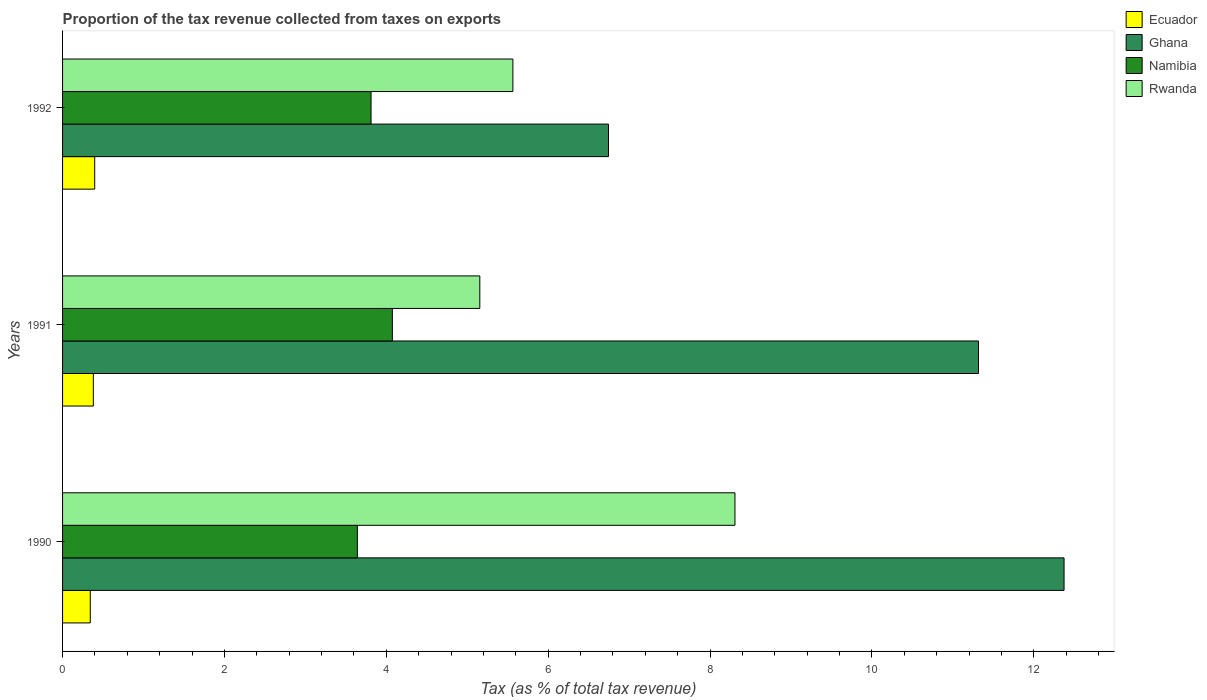Are the number of bars on each tick of the Y-axis equal?
Your response must be concise. Yes. What is the label of the 3rd group of bars from the top?
Offer a terse response. 1990. In how many cases, is the number of bars for a given year not equal to the number of legend labels?
Provide a succinct answer. 0. What is the proportion of the tax revenue collected in Namibia in 1991?
Your answer should be compact. 4.07. Across all years, what is the maximum proportion of the tax revenue collected in Rwanda?
Keep it short and to the point. 8.31. Across all years, what is the minimum proportion of the tax revenue collected in Rwanda?
Ensure brevity in your answer.  5.16. In which year was the proportion of the tax revenue collected in Rwanda maximum?
Your answer should be very brief. 1990. What is the total proportion of the tax revenue collected in Ghana in the graph?
Your answer should be compact. 30.44. What is the difference between the proportion of the tax revenue collected in Ecuador in 1990 and that in 1991?
Your answer should be very brief. -0.04. What is the difference between the proportion of the tax revenue collected in Rwanda in 1992 and the proportion of the tax revenue collected in Ghana in 1991?
Offer a terse response. -5.75. What is the average proportion of the tax revenue collected in Ecuador per year?
Make the answer very short. 0.37. In the year 1990, what is the difference between the proportion of the tax revenue collected in Namibia and proportion of the tax revenue collected in Rwanda?
Provide a succinct answer. -4.67. In how many years, is the proportion of the tax revenue collected in Namibia greater than 2.8 %?
Your answer should be compact. 3. What is the ratio of the proportion of the tax revenue collected in Namibia in 1990 to that in 1992?
Keep it short and to the point. 0.96. What is the difference between the highest and the second highest proportion of the tax revenue collected in Ghana?
Provide a short and direct response. 1.06. What is the difference between the highest and the lowest proportion of the tax revenue collected in Namibia?
Keep it short and to the point. 0.43. Is it the case that in every year, the sum of the proportion of the tax revenue collected in Ghana and proportion of the tax revenue collected in Rwanda is greater than the sum of proportion of the tax revenue collected in Ecuador and proportion of the tax revenue collected in Namibia?
Provide a short and direct response. No. What does the 1st bar from the top in 1990 represents?
Keep it short and to the point. Rwanda. What does the 4th bar from the bottom in 1991 represents?
Offer a terse response. Rwanda. How many bars are there?
Your answer should be compact. 12. What is the difference between two consecutive major ticks on the X-axis?
Offer a very short reply. 2. Are the values on the major ticks of X-axis written in scientific E-notation?
Make the answer very short. No. Does the graph contain any zero values?
Provide a short and direct response. No. What is the title of the graph?
Your response must be concise. Proportion of the tax revenue collected from taxes on exports. Does "Guyana" appear as one of the legend labels in the graph?
Keep it short and to the point. No. What is the label or title of the X-axis?
Keep it short and to the point. Tax (as % of total tax revenue). What is the Tax (as % of total tax revenue) in Ecuador in 1990?
Provide a short and direct response. 0.34. What is the Tax (as % of total tax revenue) in Ghana in 1990?
Make the answer very short. 12.37. What is the Tax (as % of total tax revenue) of Namibia in 1990?
Offer a terse response. 3.64. What is the Tax (as % of total tax revenue) in Rwanda in 1990?
Give a very brief answer. 8.31. What is the Tax (as % of total tax revenue) of Ecuador in 1991?
Offer a terse response. 0.38. What is the Tax (as % of total tax revenue) of Ghana in 1991?
Provide a succinct answer. 11.32. What is the Tax (as % of total tax revenue) in Namibia in 1991?
Offer a very short reply. 4.07. What is the Tax (as % of total tax revenue) in Rwanda in 1991?
Make the answer very short. 5.16. What is the Tax (as % of total tax revenue) in Ecuador in 1992?
Make the answer very short. 0.4. What is the Tax (as % of total tax revenue) of Ghana in 1992?
Your response must be concise. 6.75. What is the Tax (as % of total tax revenue) of Namibia in 1992?
Ensure brevity in your answer.  3.81. What is the Tax (as % of total tax revenue) in Rwanda in 1992?
Offer a terse response. 5.56. Across all years, what is the maximum Tax (as % of total tax revenue) of Ecuador?
Provide a short and direct response. 0.4. Across all years, what is the maximum Tax (as % of total tax revenue) in Ghana?
Offer a terse response. 12.37. Across all years, what is the maximum Tax (as % of total tax revenue) of Namibia?
Make the answer very short. 4.07. Across all years, what is the maximum Tax (as % of total tax revenue) in Rwanda?
Your answer should be very brief. 8.31. Across all years, what is the minimum Tax (as % of total tax revenue) of Ecuador?
Your response must be concise. 0.34. Across all years, what is the minimum Tax (as % of total tax revenue) of Ghana?
Your answer should be very brief. 6.75. Across all years, what is the minimum Tax (as % of total tax revenue) in Namibia?
Offer a very short reply. 3.64. Across all years, what is the minimum Tax (as % of total tax revenue) of Rwanda?
Ensure brevity in your answer.  5.16. What is the total Tax (as % of total tax revenue) in Ecuador in the graph?
Provide a short and direct response. 1.12. What is the total Tax (as % of total tax revenue) in Ghana in the graph?
Your answer should be compact. 30.44. What is the total Tax (as % of total tax revenue) of Namibia in the graph?
Make the answer very short. 11.53. What is the total Tax (as % of total tax revenue) in Rwanda in the graph?
Provide a succinct answer. 19.03. What is the difference between the Tax (as % of total tax revenue) in Ecuador in 1990 and that in 1991?
Offer a terse response. -0.04. What is the difference between the Tax (as % of total tax revenue) in Ghana in 1990 and that in 1991?
Offer a terse response. 1.06. What is the difference between the Tax (as % of total tax revenue) of Namibia in 1990 and that in 1991?
Offer a terse response. -0.43. What is the difference between the Tax (as % of total tax revenue) of Rwanda in 1990 and that in 1991?
Keep it short and to the point. 3.15. What is the difference between the Tax (as % of total tax revenue) in Ecuador in 1990 and that in 1992?
Offer a terse response. -0.05. What is the difference between the Tax (as % of total tax revenue) of Ghana in 1990 and that in 1992?
Give a very brief answer. 5.63. What is the difference between the Tax (as % of total tax revenue) of Namibia in 1990 and that in 1992?
Provide a short and direct response. -0.17. What is the difference between the Tax (as % of total tax revenue) in Rwanda in 1990 and that in 1992?
Ensure brevity in your answer.  2.74. What is the difference between the Tax (as % of total tax revenue) of Ecuador in 1991 and that in 1992?
Offer a very short reply. -0.02. What is the difference between the Tax (as % of total tax revenue) of Ghana in 1991 and that in 1992?
Provide a succinct answer. 4.57. What is the difference between the Tax (as % of total tax revenue) of Namibia in 1991 and that in 1992?
Your answer should be compact. 0.26. What is the difference between the Tax (as % of total tax revenue) of Rwanda in 1991 and that in 1992?
Ensure brevity in your answer.  -0.41. What is the difference between the Tax (as % of total tax revenue) of Ecuador in 1990 and the Tax (as % of total tax revenue) of Ghana in 1991?
Your answer should be very brief. -10.97. What is the difference between the Tax (as % of total tax revenue) in Ecuador in 1990 and the Tax (as % of total tax revenue) in Namibia in 1991?
Make the answer very short. -3.73. What is the difference between the Tax (as % of total tax revenue) of Ecuador in 1990 and the Tax (as % of total tax revenue) of Rwanda in 1991?
Your answer should be very brief. -4.81. What is the difference between the Tax (as % of total tax revenue) in Ghana in 1990 and the Tax (as % of total tax revenue) in Namibia in 1991?
Your answer should be very brief. 8.3. What is the difference between the Tax (as % of total tax revenue) of Ghana in 1990 and the Tax (as % of total tax revenue) of Rwanda in 1991?
Your response must be concise. 7.22. What is the difference between the Tax (as % of total tax revenue) in Namibia in 1990 and the Tax (as % of total tax revenue) in Rwanda in 1991?
Your answer should be very brief. -1.51. What is the difference between the Tax (as % of total tax revenue) in Ecuador in 1990 and the Tax (as % of total tax revenue) in Ghana in 1992?
Your answer should be very brief. -6.4. What is the difference between the Tax (as % of total tax revenue) in Ecuador in 1990 and the Tax (as % of total tax revenue) in Namibia in 1992?
Your response must be concise. -3.47. What is the difference between the Tax (as % of total tax revenue) in Ecuador in 1990 and the Tax (as % of total tax revenue) in Rwanda in 1992?
Your answer should be compact. -5.22. What is the difference between the Tax (as % of total tax revenue) in Ghana in 1990 and the Tax (as % of total tax revenue) in Namibia in 1992?
Provide a short and direct response. 8.56. What is the difference between the Tax (as % of total tax revenue) in Ghana in 1990 and the Tax (as % of total tax revenue) in Rwanda in 1992?
Make the answer very short. 6.81. What is the difference between the Tax (as % of total tax revenue) of Namibia in 1990 and the Tax (as % of total tax revenue) of Rwanda in 1992?
Your response must be concise. -1.92. What is the difference between the Tax (as % of total tax revenue) in Ecuador in 1991 and the Tax (as % of total tax revenue) in Ghana in 1992?
Provide a succinct answer. -6.37. What is the difference between the Tax (as % of total tax revenue) of Ecuador in 1991 and the Tax (as % of total tax revenue) of Namibia in 1992?
Make the answer very short. -3.43. What is the difference between the Tax (as % of total tax revenue) in Ecuador in 1991 and the Tax (as % of total tax revenue) in Rwanda in 1992?
Offer a terse response. -5.18. What is the difference between the Tax (as % of total tax revenue) of Ghana in 1991 and the Tax (as % of total tax revenue) of Namibia in 1992?
Your answer should be very brief. 7.51. What is the difference between the Tax (as % of total tax revenue) of Ghana in 1991 and the Tax (as % of total tax revenue) of Rwanda in 1992?
Give a very brief answer. 5.75. What is the difference between the Tax (as % of total tax revenue) in Namibia in 1991 and the Tax (as % of total tax revenue) in Rwanda in 1992?
Your answer should be compact. -1.49. What is the average Tax (as % of total tax revenue) of Ecuador per year?
Make the answer very short. 0.37. What is the average Tax (as % of total tax revenue) of Ghana per year?
Give a very brief answer. 10.15. What is the average Tax (as % of total tax revenue) of Namibia per year?
Give a very brief answer. 3.84. What is the average Tax (as % of total tax revenue) in Rwanda per year?
Give a very brief answer. 6.34. In the year 1990, what is the difference between the Tax (as % of total tax revenue) in Ecuador and Tax (as % of total tax revenue) in Ghana?
Your answer should be compact. -12.03. In the year 1990, what is the difference between the Tax (as % of total tax revenue) in Ecuador and Tax (as % of total tax revenue) in Namibia?
Keep it short and to the point. -3.3. In the year 1990, what is the difference between the Tax (as % of total tax revenue) of Ecuador and Tax (as % of total tax revenue) of Rwanda?
Your answer should be very brief. -7.97. In the year 1990, what is the difference between the Tax (as % of total tax revenue) of Ghana and Tax (as % of total tax revenue) of Namibia?
Provide a succinct answer. 8.73. In the year 1990, what is the difference between the Tax (as % of total tax revenue) of Ghana and Tax (as % of total tax revenue) of Rwanda?
Offer a very short reply. 4.07. In the year 1990, what is the difference between the Tax (as % of total tax revenue) of Namibia and Tax (as % of total tax revenue) of Rwanda?
Your answer should be very brief. -4.67. In the year 1991, what is the difference between the Tax (as % of total tax revenue) in Ecuador and Tax (as % of total tax revenue) in Ghana?
Your answer should be very brief. -10.94. In the year 1991, what is the difference between the Tax (as % of total tax revenue) of Ecuador and Tax (as % of total tax revenue) of Namibia?
Provide a succinct answer. -3.69. In the year 1991, what is the difference between the Tax (as % of total tax revenue) of Ecuador and Tax (as % of total tax revenue) of Rwanda?
Make the answer very short. -4.78. In the year 1991, what is the difference between the Tax (as % of total tax revenue) of Ghana and Tax (as % of total tax revenue) of Namibia?
Your answer should be very brief. 7.24. In the year 1991, what is the difference between the Tax (as % of total tax revenue) in Ghana and Tax (as % of total tax revenue) in Rwanda?
Offer a terse response. 6.16. In the year 1991, what is the difference between the Tax (as % of total tax revenue) in Namibia and Tax (as % of total tax revenue) in Rwanda?
Your answer should be compact. -1.08. In the year 1992, what is the difference between the Tax (as % of total tax revenue) in Ecuador and Tax (as % of total tax revenue) in Ghana?
Your answer should be very brief. -6.35. In the year 1992, what is the difference between the Tax (as % of total tax revenue) of Ecuador and Tax (as % of total tax revenue) of Namibia?
Keep it short and to the point. -3.41. In the year 1992, what is the difference between the Tax (as % of total tax revenue) of Ecuador and Tax (as % of total tax revenue) of Rwanda?
Give a very brief answer. -5.17. In the year 1992, what is the difference between the Tax (as % of total tax revenue) in Ghana and Tax (as % of total tax revenue) in Namibia?
Keep it short and to the point. 2.93. In the year 1992, what is the difference between the Tax (as % of total tax revenue) of Ghana and Tax (as % of total tax revenue) of Rwanda?
Provide a short and direct response. 1.18. In the year 1992, what is the difference between the Tax (as % of total tax revenue) in Namibia and Tax (as % of total tax revenue) in Rwanda?
Your answer should be compact. -1.75. What is the ratio of the Tax (as % of total tax revenue) in Ecuador in 1990 to that in 1991?
Provide a succinct answer. 0.9. What is the ratio of the Tax (as % of total tax revenue) of Ghana in 1990 to that in 1991?
Keep it short and to the point. 1.09. What is the ratio of the Tax (as % of total tax revenue) in Namibia in 1990 to that in 1991?
Give a very brief answer. 0.89. What is the ratio of the Tax (as % of total tax revenue) of Rwanda in 1990 to that in 1991?
Provide a succinct answer. 1.61. What is the ratio of the Tax (as % of total tax revenue) in Ecuador in 1990 to that in 1992?
Provide a short and direct response. 0.86. What is the ratio of the Tax (as % of total tax revenue) of Ghana in 1990 to that in 1992?
Offer a terse response. 1.83. What is the ratio of the Tax (as % of total tax revenue) in Namibia in 1990 to that in 1992?
Offer a terse response. 0.96. What is the ratio of the Tax (as % of total tax revenue) of Rwanda in 1990 to that in 1992?
Keep it short and to the point. 1.49. What is the ratio of the Tax (as % of total tax revenue) of Ecuador in 1991 to that in 1992?
Ensure brevity in your answer.  0.96. What is the ratio of the Tax (as % of total tax revenue) in Ghana in 1991 to that in 1992?
Provide a succinct answer. 1.68. What is the ratio of the Tax (as % of total tax revenue) of Namibia in 1991 to that in 1992?
Your answer should be compact. 1.07. What is the ratio of the Tax (as % of total tax revenue) in Rwanda in 1991 to that in 1992?
Your response must be concise. 0.93. What is the difference between the highest and the second highest Tax (as % of total tax revenue) in Ecuador?
Make the answer very short. 0.02. What is the difference between the highest and the second highest Tax (as % of total tax revenue) in Ghana?
Provide a succinct answer. 1.06. What is the difference between the highest and the second highest Tax (as % of total tax revenue) of Namibia?
Your answer should be very brief. 0.26. What is the difference between the highest and the second highest Tax (as % of total tax revenue) of Rwanda?
Offer a very short reply. 2.74. What is the difference between the highest and the lowest Tax (as % of total tax revenue) of Ecuador?
Your answer should be very brief. 0.05. What is the difference between the highest and the lowest Tax (as % of total tax revenue) of Ghana?
Keep it short and to the point. 5.63. What is the difference between the highest and the lowest Tax (as % of total tax revenue) in Namibia?
Your response must be concise. 0.43. What is the difference between the highest and the lowest Tax (as % of total tax revenue) of Rwanda?
Your answer should be very brief. 3.15. 